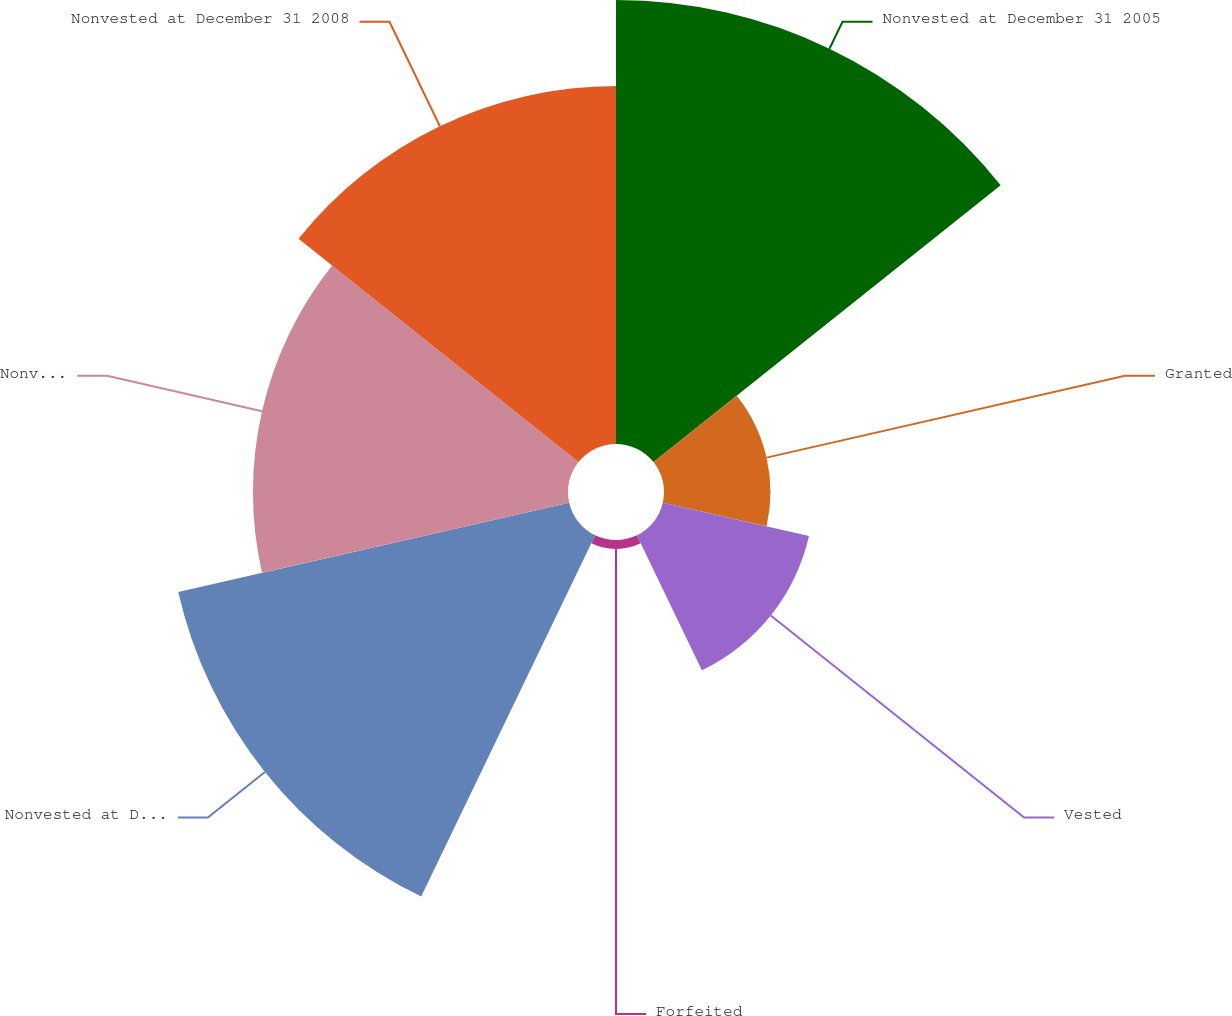<chart> <loc_0><loc_0><loc_500><loc_500><pie_chart><fcel>Nonvested at December 31 2005<fcel>Granted<fcel>Vested<fcel>Forfeited<fcel>Nonvested at December 31 2006<fcel>Nonvested at December 31 2007<fcel>Nonvested at December 31 2008<nl><fcel>24.9%<fcel>5.97%<fcel>8.41%<fcel>0.5%<fcel>22.49%<fcel>17.67%<fcel>20.08%<nl></chart> 